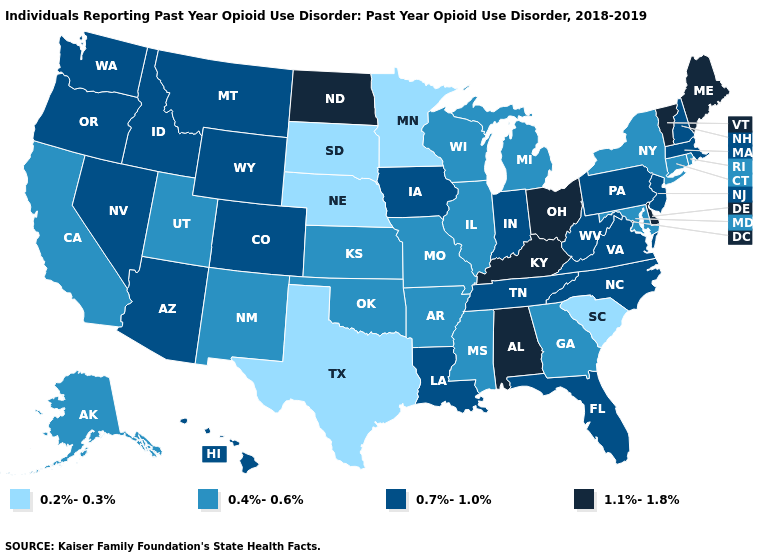What is the value of Mississippi?
Be succinct. 0.4%-0.6%. What is the value of Arkansas?
Keep it brief. 0.4%-0.6%. What is the value of Montana?
Be succinct. 0.7%-1.0%. Does California have the lowest value in the West?
Give a very brief answer. Yes. How many symbols are there in the legend?
Answer briefly. 4. Name the states that have a value in the range 1.1%-1.8%?
Keep it brief. Alabama, Delaware, Kentucky, Maine, North Dakota, Ohio, Vermont. Does the first symbol in the legend represent the smallest category?
Concise answer only. Yes. Does the first symbol in the legend represent the smallest category?
Quick response, please. Yes. What is the value of Maine?
Quick response, please. 1.1%-1.8%. Among the states that border Kentucky , does Virginia have the lowest value?
Give a very brief answer. No. Name the states that have a value in the range 0.4%-0.6%?
Answer briefly. Alaska, Arkansas, California, Connecticut, Georgia, Illinois, Kansas, Maryland, Michigan, Mississippi, Missouri, New Mexico, New York, Oklahoma, Rhode Island, Utah, Wisconsin. Which states have the lowest value in the MidWest?
Concise answer only. Minnesota, Nebraska, South Dakota. Which states have the highest value in the USA?
Short answer required. Alabama, Delaware, Kentucky, Maine, North Dakota, Ohio, Vermont. What is the highest value in the Northeast ?
Answer briefly. 1.1%-1.8%. 